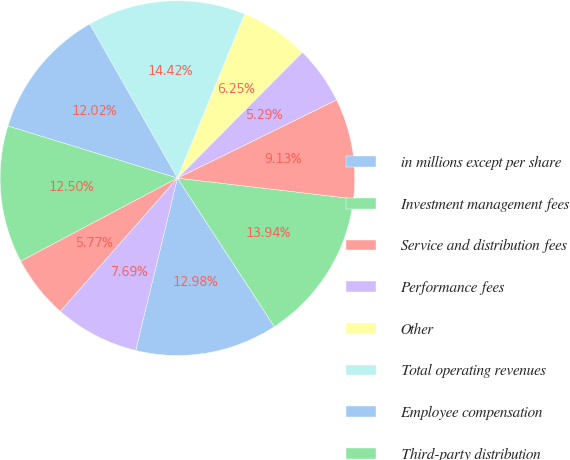<chart> <loc_0><loc_0><loc_500><loc_500><pie_chart><fcel>in millions except per share<fcel>Investment management fees<fcel>Service and distribution fees<fcel>Performance fees<fcel>Other<fcel>Total operating revenues<fcel>Employee compensation<fcel>Third-party distribution<fcel>Marketing<fcel>Property office and technology<nl><fcel>12.98%<fcel>13.94%<fcel>9.13%<fcel>5.29%<fcel>6.25%<fcel>14.42%<fcel>12.02%<fcel>12.5%<fcel>5.77%<fcel>7.69%<nl></chart> 